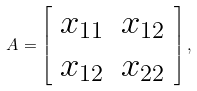<formula> <loc_0><loc_0><loc_500><loc_500>A = \left [ \begin{array} { c c } x _ { 1 1 } & x _ { 1 2 } \\ x _ { 1 2 } & x _ { 2 2 } \end{array} \right ] ,</formula> 